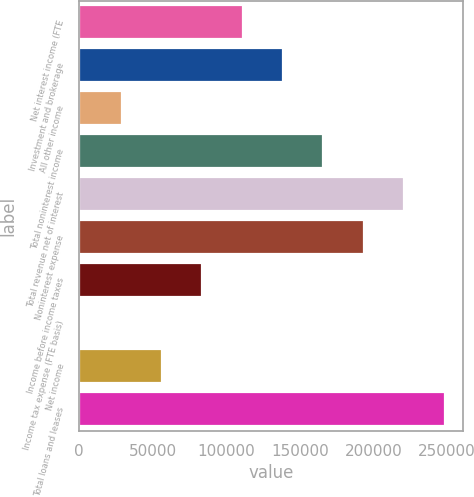<chart> <loc_0><loc_0><loc_500><loc_500><bar_chart><fcel>Net interest income (FTE<fcel>Investment and brokerage<fcel>All other income<fcel>Total noninterest income<fcel>Total revenue net of interest<fcel>Noninterest expense<fcel>Income before income taxes<fcel>Income tax expense (FTE basis)<fcel>Net income<fcel>Total loans and leases<nl><fcel>111245<fcel>138682<fcel>28934.8<fcel>166119<fcel>220992<fcel>193556<fcel>83808.4<fcel>1498<fcel>56371.6<fcel>248429<nl></chart> 